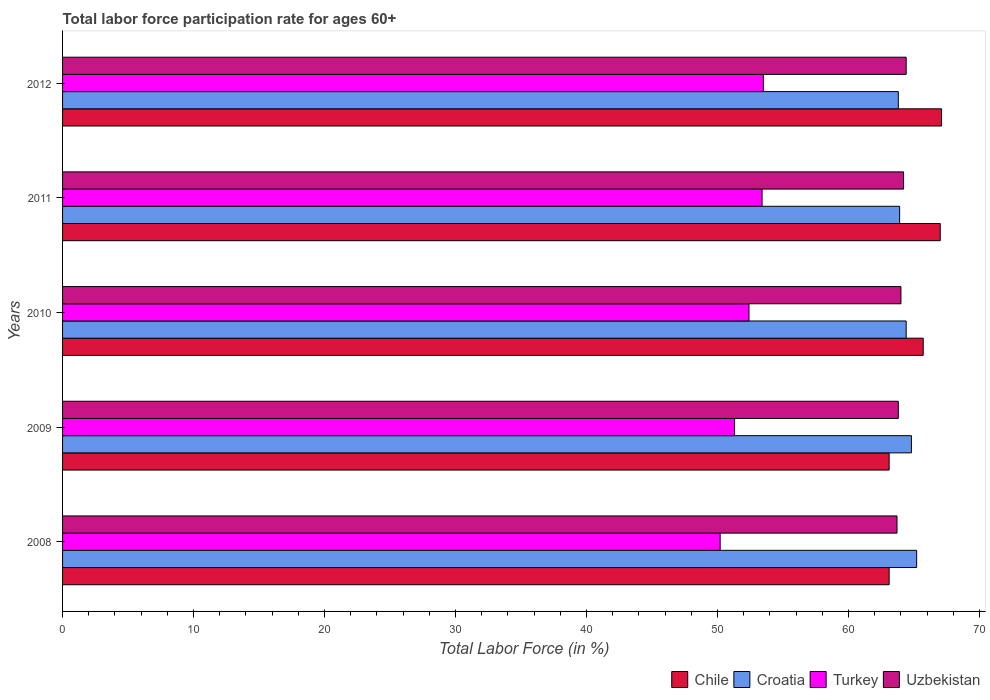Are the number of bars per tick equal to the number of legend labels?
Ensure brevity in your answer.  Yes. How many bars are there on the 1st tick from the top?
Provide a short and direct response. 4. How many bars are there on the 4th tick from the bottom?
Provide a succinct answer. 4. What is the label of the 2nd group of bars from the top?
Your response must be concise. 2011. What is the labor force participation rate in Croatia in 2008?
Make the answer very short. 65.2. Across all years, what is the maximum labor force participation rate in Turkey?
Provide a succinct answer. 53.5. Across all years, what is the minimum labor force participation rate in Uzbekistan?
Your answer should be very brief. 63.7. What is the total labor force participation rate in Turkey in the graph?
Your answer should be very brief. 260.8. What is the difference between the labor force participation rate in Uzbekistan in 2011 and that in 2012?
Offer a very short reply. -0.2. What is the difference between the labor force participation rate in Chile in 2010 and the labor force participation rate in Uzbekistan in 2012?
Make the answer very short. 1.3. What is the average labor force participation rate in Turkey per year?
Make the answer very short. 52.16. In the year 2008, what is the difference between the labor force participation rate in Chile and labor force participation rate in Croatia?
Offer a terse response. -2.1. What is the ratio of the labor force participation rate in Croatia in 2009 to that in 2010?
Your response must be concise. 1.01. What is the difference between the highest and the second highest labor force participation rate in Chile?
Offer a very short reply. 0.1. What is the difference between the highest and the lowest labor force participation rate in Turkey?
Keep it short and to the point. 3.3. In how many years, is the labor force participation rate in Turkey greater than the average labor force participation rate in Turkey taken over all years?
Keep it short and to the point. 3. Is the sum of the labor force participation rate in Croatia in 2009 and 2011 greater than the maximum labor force participation rate in Chile across all years?
Give a very brief answer. Yes. Is it the case that in every year, the sum of the labor force participation rate in Turkey and labor force participation rate in Uzbekistan is greater than the sum of labor force participation rate in Croatia and labor force participation rate in Chile?
Your answer should be very brief. No. What does the 4th bar from the top in 2012 represents?
Your answer should be compact. Chile. What does the 4th bar from the bottom in 2011 represents?
Offer a very short reply. Uzbekistan. How many bars are there?
Provide a succinct answer. 20. How many years are there in the graph?
Offer a terse response. 5. Are the values on the major ticks of X-axis written in scientific E-notation?
Provide a succinct answer. No. Does the graph contain any zero values?
Give a very brief answer. No. Does the graph contain grids?
Your response must be concise. No. Where does the legend appear in the graph?
Your answer should be compact. Bottom right. How many legend labels are there?
Your answer should be very brief. 4. How are the legend labels stacked?
Give a very brief answer. Horizontal. What is the title of the graph?
Offer a terse response. Total labor force participation rate for ages 60+. Does "Papua New Guinea" appear as one of the legend labels in the graph?
Your answer should be compact. No. What is the label or title of the X-axis?
Your response must be concise. Total Labor Force (in %). What is the label or title of the Y-axis?
Provide a short and direct response. Years. What is the Total Labor Force (in %) in Chile in 2008?
Make the answer very short. 63.1. What is the Total Labor Force (in %) in Croatia in 2008?
Offer a terse response. 65.2. What is the Total Labor Force (in %) of Turkey in 2008?
Your response must be concise. 50.2. What is the Total Labor Force (in %) of Uzbekistan in 2008?
Give a very brief answer. 63.7. What is the Total Labor Force (in %) in Chile in 2009?
Ensure brevity in your answer.  63.1. What is the Total Labor Force (in %) in Croatia in 2009?
Ensure brevity in your answer.  64.8. What is the Total Labor Force (in %) in Turkey in 2009?
Provide a short and direct response. 51.3. What is the Total Labor Force (in %) in Uzbekistan in 2009?
Your answer should be very brief. 63.8. What is the Total Labor Force (in %) of Chile in 2010?
Give a very brief answer. 65.7. What is the Total Labor Force (in %) in Croatia in 2010?
Give a very brief answer. 64.4. What is the Total Labor Force (in %) in Turkey in 2010?
Make the answer very short. 52.4. What is the Total Labor Force (in %) in Uzbekistan in 2010?
Make the answer very short. 64. What is the Total Labor Force (in %) in Chile in 2011?
Give a very brief answer. 67. What is the Total Labor Force (in %) of Croatia in 2011?
Offer a very short reply. 63.9. What is the Total Labor Force (in %) in Turkey in 2011?
Your answer should be compact. 53.4. What is the Total Labor Force (in %) of Uzbekistan in 2011?
Your answer should be compact. 64.2. What is the Total Labor Force (in %) in Chile in 2012?
Your answer should be very brief. 67.1. What is the Total Labor Force (in %) in Croatia in 2012?
Your answer should be very brief. 63.8. What is the Total Labor Force (in %) in Turkey in 2012?
Give a very brief answer. 53.5. What is the Total Labor Force (in %) in Uzbekistan in 2012?
Offer a terse response. 64.4. Across all years, what is the maximum Total Labor Force (in %) of Chile?
Provide a succinct answer. 67.1. Across all years, what is the maximum Total Labor Force (in %) in Croatia?
Ensure brevity in your answer.  65.2. Across all years, what is the maximum Total Labor Force (in %) of Turkey?
Ensure brevity in your answer.  53.5. Across all years, what is the maximum Total Labor Force (in %) of Uzbekistan?
Offer a terse response. 64.4. Across all years, what is the minimum Total Labor Force (in %) in Chile?
Provide a succinct answer. 63.1. Across all years, what is the minimum Total Labor Force (in %) of Croatia?
Keep it short and to the point. 63.8. Across all years, what is the minimum Total Labor Force (in %) in Turkey?
Your answer should be very brief. 50.2. Across all years, what is the minimum Total Labor Force (in %) of Uzbekistan?
Give a very brief answer. 63.7. What is the total Total Labor Force (in %) of Chile in the graph?
Your response must be concise. 326. What is the total Total Labor Force (in %) in Croatia in the graph?
Ensure brevity in your answer.  322.1. What is the total Total Labor Force (in %) in Turkey in the graph?
Offer a terse response. 260.8. What is the total Total Labor Force (in %) in Uzbekistan in the graph?
Keep it short and to the point. 320.1. What is the difference between the Total Labor Force (in %) of Croatia in 2008 and that in 2009?
Provide a short and direct response. 0.4. What is the difference between the Total Labor Force (in %) in Turkey in 2008 and that in 2009?
Keep it short and to the point. -1.1. What is the difference between the Total Labor Force (in %) in Uzbekistan in 2008 and that in 2009?
Your response must be concise. -0.1. What is the difference between the Total Labor Force (in %) of Chile in 2008 and that in 2010?
Your answer should be very brief. -2.6. What is the difference between the Total Labor Force (in %) in Turkey in 2008 and that in 2010?
Ensure brevity in your answer.  -2.2. What is the difference between the Total Labor Force (in %) in Chile in 2008 and that in 2011?
Ensure brevity in your answer.  -3.9. What is the difference between the Total Labor Force (in %) of Croatia in 2008 and that in 2011?
Keep it short and to the point. 1.3. What is the difference between the Total Labor Force (in %) of Turkey in 2008 and that in 2011?
Make the answer very short. -3.2. What is the difference between the Total Labor Force (in %) of Chile in 2008 and that in 2012?
Provide a succinct answer. -4. What is the difference between the Total Labor Force (in %) of Turkey in 2008 and that in 2012?
Provide a succinct answer. -3.3. What is the difference between the Total Labor Force (in %) in Uzbekistan in 2008 and that in 2012?
Offer a very short reply. -0.7. What is the difference between the Total Labor Force (in %) in Croatia in 2009 and that in 2010?
Offer a very short reply. 0.4. What is the difference between the Total Labor Force (in %) of Uzbekistan in 2009 and that in 2010?
Provide a short and direct response. -0.2. What is the difference between the Total Labor Force (in %) of Turkey in 2009 and that in 2011?
Your response must be concise. -2.1. What is the difference between the Total Labor Force (in %) of Uzbekistan in 2009 and that in 2011?
Offer a terse response. -0.4. What is the difference between the Total Labor Force (in %) in Croatia in 2009 and that in 2012?
Your response must be concise. 1. What is the difference between the Total Labor Force (in %) of Uzbekistan in 2009 and that in 2012?
Your answer should be compact. -0.6. What is the difference between the Total Labor Force (in %) of Turkey in 2010 and that in 2011?
Make the answer very short. -1. What is the difference between the Total Labor Force (in %) in Uzbekistan in 2010 and that in 2011?
Your response must be concise. -0.2. What is the difference between the Total Labor Force (in %) of Turkey in 2011 and that in 2012?
Make the answer very short. -0.1. What is the difference between the Total Labor Force (in %) in Uzbekistan in 2011 and that in 2012?
Give a very brief answer. -0.2. What is the difference between the Total Labor Force (in %) of Chile in 2008 and the Total Labor Force (in %) of Croatia in 2009?
Ensure brevity in your answer.  -1.7. What is the difference between the Total Labor Force (in %) of Croatia in 2008 and the Total Labor Force (in %) of Uzbekistan in 2009?
Offer a terse response. 1.4. What is the difference between the Total Labor Force (in %) in Turkey in 2008 and the Total Labor Force (in %) in Uzbekistan in 2009?
Make the answer very short. -13.6. What is the difference between the Total Labor Force (in %) in Chile in 2008 and the Total Labor Force (in %) in Turkey in 2010?
Ensure brevity in your answer.  10.7. What is the difference between the Total Labor Force (in %) of Chile in 2008 and the Total Labor Force (in %) of Uzbekistan in 2010?
Offer a very short reply. -0.9. What is the difference between the Total Labor Force (in %) of Croatia in 2008 and the Total Labor Force (in %) of Turkey in 2010?
Keep it short and to the point. 12.8. What is the difference between the Total Labor Force (in %) in Croatia in 2008 and the Total Labor Force (in %) in Uzbekistan in 2010?
Offer a very short reply. 1.2. What is the difference between the Total Labor Force (in %) of Chile in 2008 and the Total Labor Force (in %) of Turkey in 2011?
Provide a short and direct response. 9.7. What is the difference between the Total Labor Force (in %) of Croatia in 2008 and the Total Labor Force (in %) of Turkey in 2011?
Your answer should be very brief. 11.8. What is the difference between the Total Labor Force (in %) of Croatia in 2008 and the Total Labor Force (in %) of Uzbekistan in 2011?
Keep it short and to the point. 1. What is the difference between the Total Labor Force (in %) of Turkey in 2008 and the Total Labor Force (in %) of Uzbekistan in 2011?
Your answer should be very brief. -14. What is the difference between the Total Labor Force (in %) in Chile in 2008 and the Total Labor Force (in %) in Croatia in 2012?
Your answer should be very brief. -0.7. What is the difference between the Total Labor Force (in %) of Croatia in 2008 and the Total Labor Force (in %) of Turkey in 2012?
Provide a succinct answer. 11.7. What is the difference between the Total Labor Force (in %) in Chile in 2009 and the Total Labor Force (in %) in Turkey in 2010?
Make the answer very short. 10.7. What is the difference between the Total Labor Force (in %) in Croatia in 2009 and the Total Labor Force (in %) in Uzbekistan in 2010?
Make the answer very short. 0.8. What is the difference between the Total Labor Force (in %) of Chile in 2009 and the Total Labor Force (in %) of Croatia in 2011?
Keep it short and to the point. -0.8. What is the difference between the Total Labor Force (in %) of Chile in 2009 and the Total Labor Force (in %) of Turkey in 2011?
Give a very brief answer. 9.7. What is the difference between the Total Labor Force (in %) in Chile in 2009 and the Total Labor Force (in %) in Croatia in 2012?
Keep it short and to the point. -0.7. What is the difference between the Total Labor Force (in %) of Turkey in 2009 and the Total Labor Force (in %) of Uzbekistan in 2012?
Your answer should be very brief. -13.1. What is the difference between the Total Labor Force (in %) of Chile in 2010 and the Total Labor Force (in %) of Croatia in 2011?
Give a very brief answer. 1.8. What is the difference between the Total Labor Force (in %) of Croatia in 2010 and the Total Labor Force (in %) of Turkey in 2011?
Your answer should be very brief. 11. What is the difference between the Total Labor Force (in %) of Croatia in 2010 and the Total Labor Force (in %) of Uzbekistan in 2011?
Your response must be concise. 0.2. What is the difference between the Total Labor Force (in %) of Turkey in 2010 and the Total Labor Force (in %) of Uzbekistan in 2011?
Give a very brief answer. -11.8. What is the difference between the Total Labor Force (in %) of Chile in 2010 and the Total Labor Force (in %) of Turkey in 2012?
Keep it short and to the point. 12.2. What is the difference between the Total Labor Force (in %) in Chile in 2010 and the Total Labor Force (in %) in Uzbekistan in 2012?
Provide a short and direct response. 1.3. What is the difference between the Total Labor Force (in %) of Turkey in 2010 and the Total Labor Force (in %) of Uzbekistan in 2012?
Keep it short and to the point. -12. What is the difference between the Total Labor Force (in %) in Croatia in 2011 and the Total Labor Force (in %) in Turkey in 2012?
Ensure brevity in your answer.  10.4. What is the difference between the Total Labor Force (in %) in Croatia in 2011 and the Total Labor Force (in %) in Uzbekistan in 2012?
Provide a short and direct response. -0.5. What is the average Total Labor Force (in %) of Chile per year?
Offer a terse response. 65.2. What is the average Total Labor Force (in %) in Croatia per year?
Give a very brief answer. 64.42. What is the average Total Labor Force (in %) in Turkey per year?
Provide a succinct answer. 52.16. What is the average Total Labor Force (in %) in Uzbekistan per year?
Offer a very short reply. 64.02. In the year 2008, what is the difference between the Total Labor Force (in %) in Chile and Total Labor Force (in %) in Turkey?
Offer a terse response. 12.9. In the year 2008, what is the difference between the Total Labor Force (in %) in Chile and Total Labor Force (in %) in Uzbekistan?
Ensure brevity in your answer.  -0.6. In the year 2008, what is the difference between the Total Labor Force (in %) in Turkey and Total Labor Force (in %) in Uzbekistan?
Ensure brevity in your answer.  -13.5. In the year 2009, what is the difference between the Total Labor Force (in %) in Chile and Total Labor Force (in %) in Croatia?
Your answer should be compact. -1.7. In the year 2009, what is the difference between the Total Labor Force (in %) of Croatia and Total Labor Force (in %) of Turkey?
Ensure brevity in your answer.  13.5. In the year 2009, what is the difference between the Total Labor Force (in %) in Turkey and Total Labor Force (in %) in Uzbekistan?
Your answer should be compact. -12.5. In the year 2010, what is the difference between the Total Labor Force (in %) in Chile and Total Labor Force (in %) in Croatia?
Offer a terse response. 1.3. In the year 2010, what is the difference between the Total Labor Force (in %) in Chile and Total Labor Force (in %) in Turkey?
Your response must be concise. 13.3. In the year 2010, what is the difference between the Total Labor Force (in %) of Chile and Total Labor Force (in %) of Uzbekistan?
Your answer should be very brief. 1.7. In the year 2010, what is the difference between the Total Labor Force (in %) in Croatia and Total Labor Force (in %) in Uzbekistan?
Ensure brevity in your answer.  0.4. In the year 2011, what is the difference between the Total Labor Force (in %) of Croatia and Total Labor Force (in %) of Turkey?
Your response must be concise. 10.5. In the year 2011, what is the difference between the Total Labor Force (in %) of Turkey and Total Labor Force (in %) of Uzbekistan?
Your answer should be compact. -10.8. In the year 2012, what is the difference between the Total Labor Force (in %) of Chile and Total Labor Force (in %) of Turkey?
Your answer should be very brief. 13.6. In the year 2012, what is the difference between the Total Labor Force (in %) in Croatia and Total Labor Force (in %) in Uzbekistan?
Keep it short and to the point. -0.6. What is the ratio of the Total Labor Force (in %) in Chile in 2008 to that in 2009?
Offer a terse response. 1. What is the ratio of the Total Labor Force (in %) in Croatia in 2008 to that in 2009?
Offer a very short reply. 1.01. What is the ratio of the Total Labor Force (in %) in Turkey in 2008 to that in 2009?
Provide a short and direct response. 0.98. What is the ratio of the Total Labor Force (in %) in Uzbekistan in 2008 to that in 2009?
Keep it short and to the point. 1. What is the ratio of the Total Labor Force (in %) of Chile in 2008 to that in 2010?
Keep it short and to the point. 0.96. What is the ratio of the Total Labor Force (in %) of Croatia in 2008 to that in 2010?
Provide a succinct answer. 1.01. What is the ratio of the Total Labor Force (in %) in Turkey in 2008 to that in 2010?
Provide a succinct answer. 0.96. What is the ratio of the Total Labor Force (in %) in Uzbekistan in 2008 to that in 2010?
Your answer should be very brief. 1. What is the ratio of the Total Labor Force (in %) in Chile in 2008 to that in 2011?
Provide a short and direct response. 0.94. What is the ratio of the Total Labor Force (in %) in Croatia in 2008 to that in 2011?
Ensure brevity in your answer.  1.02. What is the ratio of the Total Labor Force (in %) in Turkey in 2008 to that in 2011?
Your response must be concise. 0.94. What is the ratio of the Total Labor Force (in %) of Chile in 2008 to that in 2012?
Offer a very short reply. 0.94. What is the ratio of the Total Labor Force (in %) in Croatia in 2008 to that in 2012?
Keep it short and to the point. 1.02. What is the ratio of the Total Labor Force (in %) in Turkey in 2008 to that in 2012?
Provide a short and direct response. 0.94. What is the ratio of the Total Labor Force (in %) in Uzbekistan in 2008 to that in 2012?
Make the answer very short. 0.99. What is the ratio of the Total Labor Force (in %) of Chile in 2009 to that in 2010?
Offer a very short reply. 0.96. What is the ratio of the Total Labor Force (in %) in Chile in 2009 to that in 2011?
Provide a short and direct response. 0.94. What is the ratio of the Total Labor Force (in %) in Croatia in 2009 to that in 2011?
Keep it short and to the point. 1.01. What is the ratio of the Total Labor Force (in %) in Turkey in 2009 to that in 2011?
Ensure brevity in your answer.  0.96. What is the ratio of the Total Labor Force (in %) in Chile in 2009 to that in 2012?
Keep it short and to the point. 0.94. What is the ratio of the Total Labor Force (in %) in Croatia in 2009 to that in 2012?
Provide a succinct answer. 1.02. What is the ratio of the Total Labor Force (in %) in Turkey in 2009 to that in 2012?
Your answer should be compact. 0.96. What is the ratio of the Total Labor Force (in %) of Chile in 2010 to that in 2011?
Offer a terse response. 0.98. What is the ratio of the Total Labor Force (in %) in Turkey in 2010 to that in 2011?
Your response must be concise. 0.98. What is the ratio of the Total Labor Force (in %) of Uzbekistan in 2010 to that in 2011?
Offer a terse response. 1. What is the ratio of the Total Labor Force (in %) in Chile in 2010 to that in 2012?
Provide a succinct answer. 0.98. What is the ratio of the Total Labor Force (in %) of Croatia in 2010 to that in 2012?
Your answer should be very brief. 1.01. What is the ratio of the Total Labor Force (in %) in Turkey in 2010 to that in 2012?
Provide a succinct answer. 0.98. What is the ratio of the Total Labor Force (in %) of Turkey in 2011 to that in 2012?
Offer a terse response. 1. What is the difference between the highest and the second highest Total Labor Force (in %) in Chile?
Your answer should be compact. 0.1. What is the difference between the highest and the second highest Total Labor Force (in %) of Croatia?
Offer a very short reply. 0.4. What is the difference between the highest and the second highest Total Labor Force (in %) in Turkey?
Your response must be concise. 0.1. What is the difference between the highest and the lowest Total Labor Force (in %) of Chile?
Provide a succinct answer. 4. 